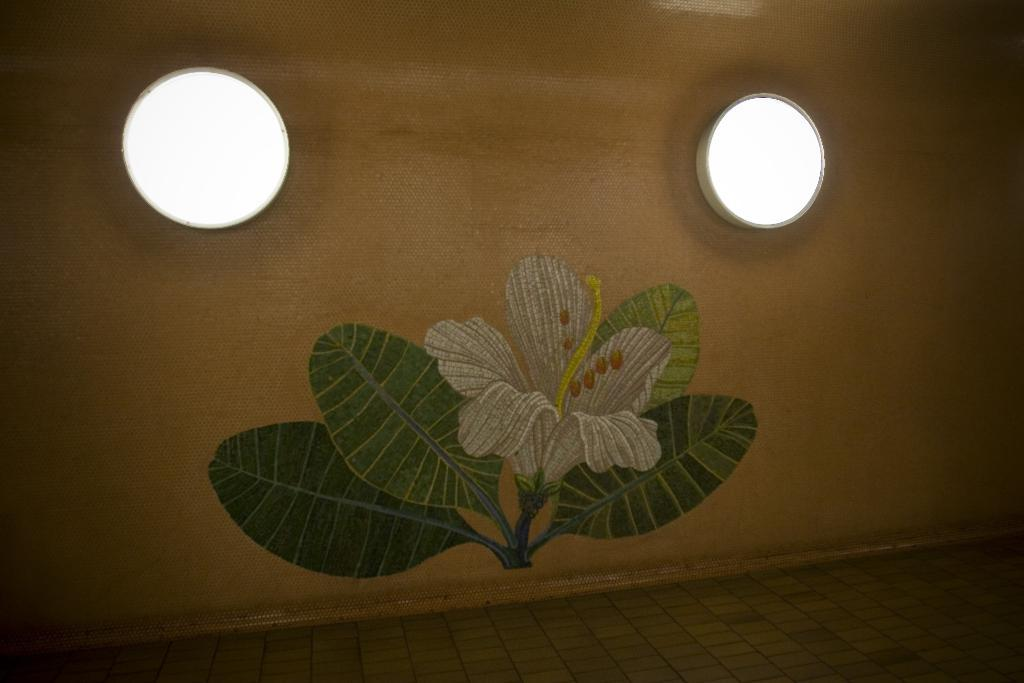What is present on the wall in the image? There is a painting on the wall in the image. What color is the wall? The wall is cream-colored. Can you describe the painting on the wall? Unfortunately, the facts provided do not give any details about the painting. What type of plant is depicted in the image? There is a flower and leaves in the image, but the facts do not specify the type of plant. How many lights are attached to the wall? There are two lights fixed to the wall. How many hens are sitting on the government building in the image? There are no hens or government buildings present in the image. What type of frogs can be seen interacting with the lights on the wall? There are no frogs present in the image; only the wall, painting, flower, leaves, and lights are visible. 